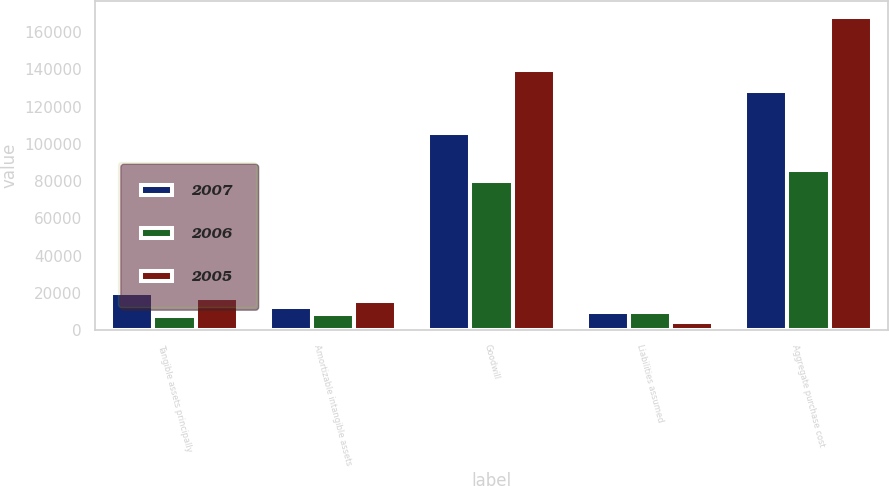Convert chart. <chart><loc_0><loc_0><loc_500><loc_500><stacked_bar_chart><ecel><fcel>Tangible assets principally<fcel>Amortizable intangible assets<fcel>Goodwill<fcel>Liabilities assumed<fcel>Aggregate purchase cost<nl><fcel>2007<fcel>20085<fcel>12271<fcel>105609<fcel>9676<fcel>128289<nl><fcel>2006<fcel>7623<fcel>8584<fcel>79948<fcel>9912<fcel>86243<nl><fcel>2005<fcel>17381<fcel>15631<fcel>139485<fcel>4257<fcel>168240<nl></chart> 